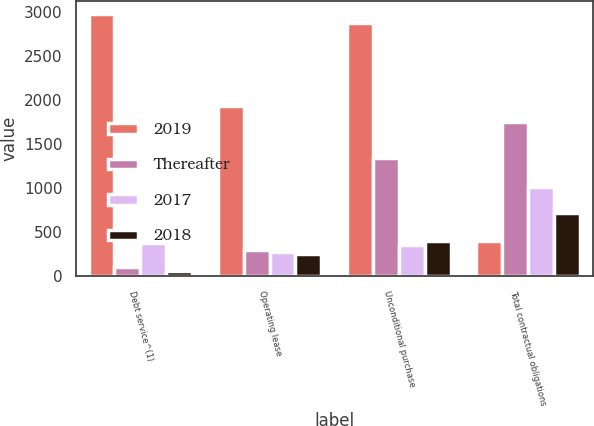<chart> <loc_0><loc_0><loc_500><loc_500><stacked_bar_chart><ecel><fcel>Debt service^(1)<fcel>Operating lease<fcel>Unconditional purchase<fcel>Total contractual obligations<nl><fcel>2019<fcel>2970.6<fcel>1927.8<fcel>2871.9<fcel>401.5<nl><fcel>Thereafter<fcel>104.4<fcel>299.8<fcel>1338.9<fcel>1748.3<nl><fcel>2017<fcel>378.4<fcel>279.4<fcel>358.4<fcel>1016.2<nl><fcel>2018<fcel>59.4<fcel>252.5<fcel>401.5<fcel>713.4<nl></chart> 